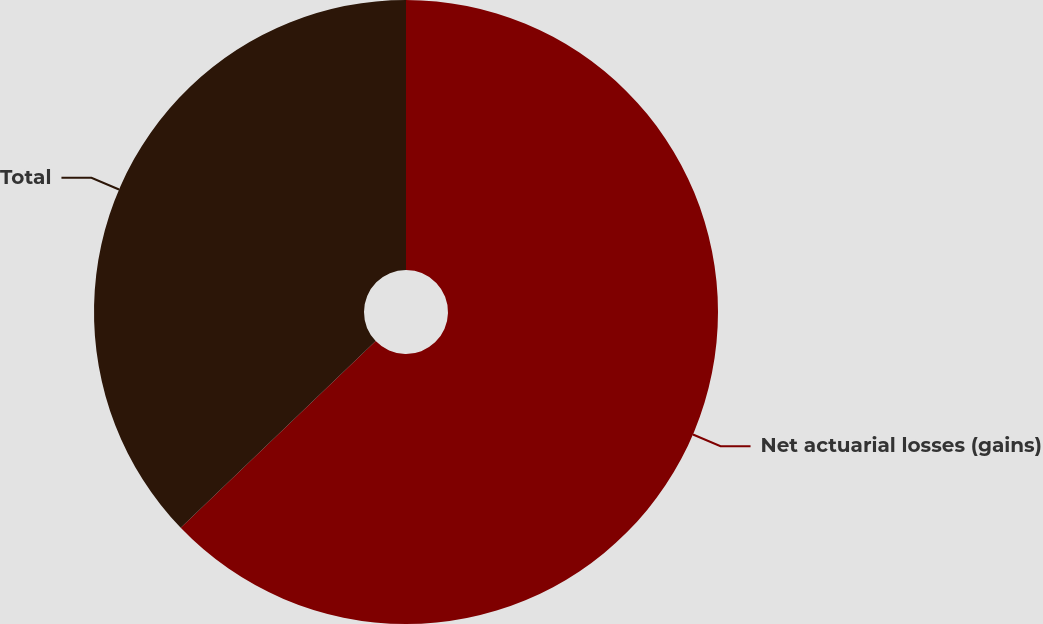<chart> <loc_0><loc_0><loc_500><loc_500><pie_chart><fcel>Net actuarial losses (gains)<fcel>Total<nl><fcel>62.84%<fcel>37.16%<nl></chart> 